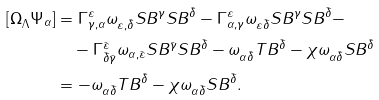Convert formula to latex. <formula><loc_0><loc_0><loc_500><loc_500>{ [ \Omega } _ { \Lambda } \Psi _ { \alpha } ] & = \Gamma ^ { \varepsilon } _ { \gamma , \alpha } \omega _ { \varepsilon , \bar { \delta } } S B ^ { \gamma } S B ^ { \bar { \delta } } - \Gamma ^ { \varepsilon } _ { \alpha , \gamma } \omega _ { \varepsilon \bar { \delta } } S B ^ { \gamma } S B ^ { \bar { \delta } } - \\ & \quad - \Gamma ^ { \bar { \varepsilon } } _ { \bar { \delta } \bar { \gamma } } \omega _ { \alpha , \bar { \varepsilon } } S B ^ { \bar { \gamma } } S B ^ { \bar { \delta } } - \omega _ { \alpha \bar { \delta } } T B ^ { \bar { \delta } } - \chi \omega _ { \alpha \bar { \delta } } S B ^ { \bar { \delta } } \\ & = - \omega _ { \alpha \bar { \delta } } T B ^ { \bar { \delta } } - \chi \omega _ { \alpha \bar { \delta } } S B ^ { \bar { \delta } } .</formula> 